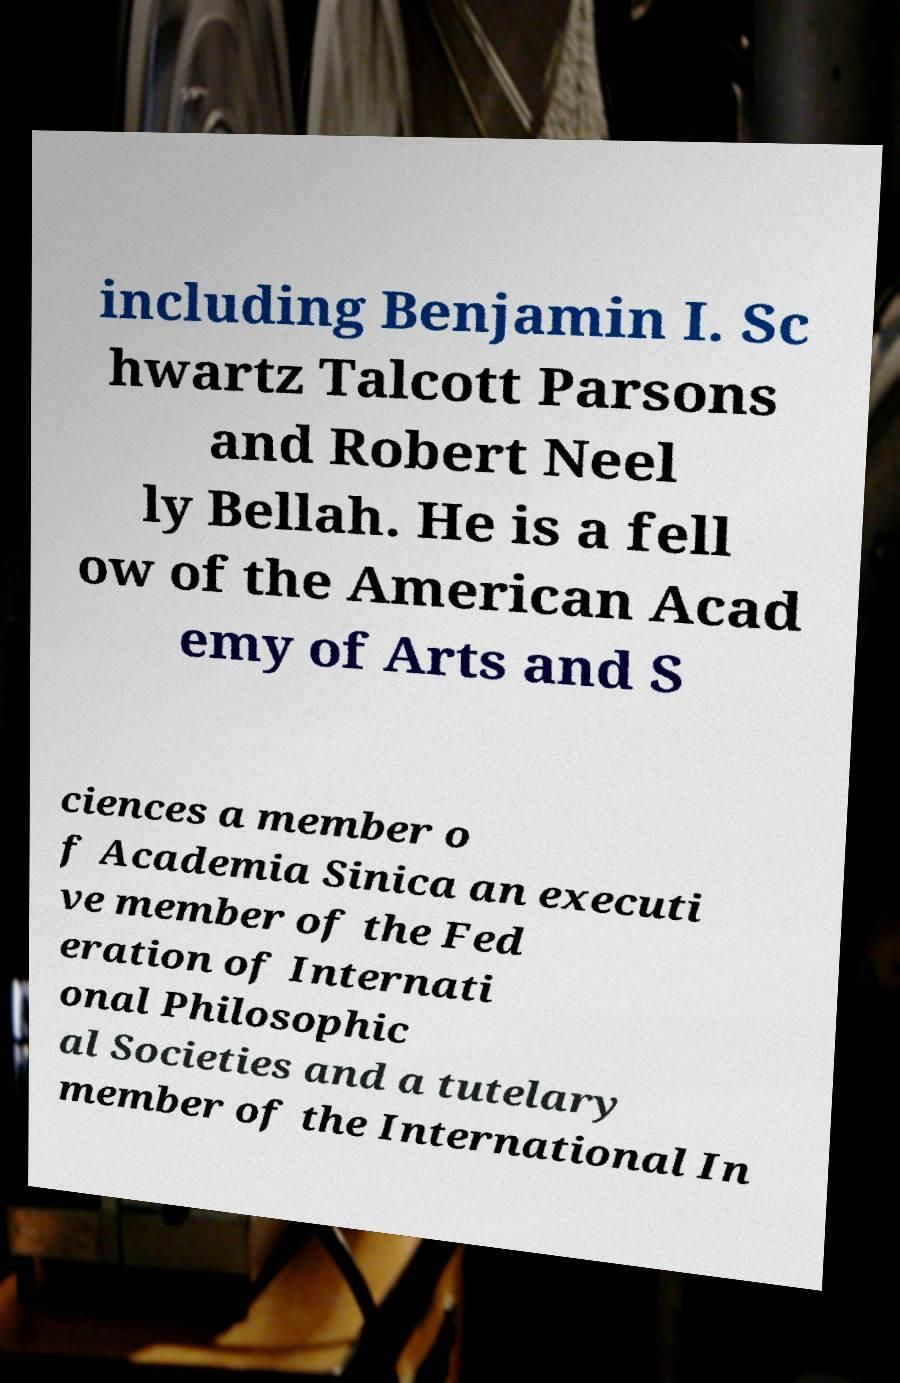For documentation purposes, I need the text within this image transcribed. Could you provide that? including Benjamin I. Sc hwartz Talcott Parsons and Robert Neel ly Bellah. He is a fell ow of the American Acad emy of Arts and S ciences a member o f Academia Sinica an executi ve member of the Fed eration of Internati onal Philosophic al Societies and a tutelary member of the International In 